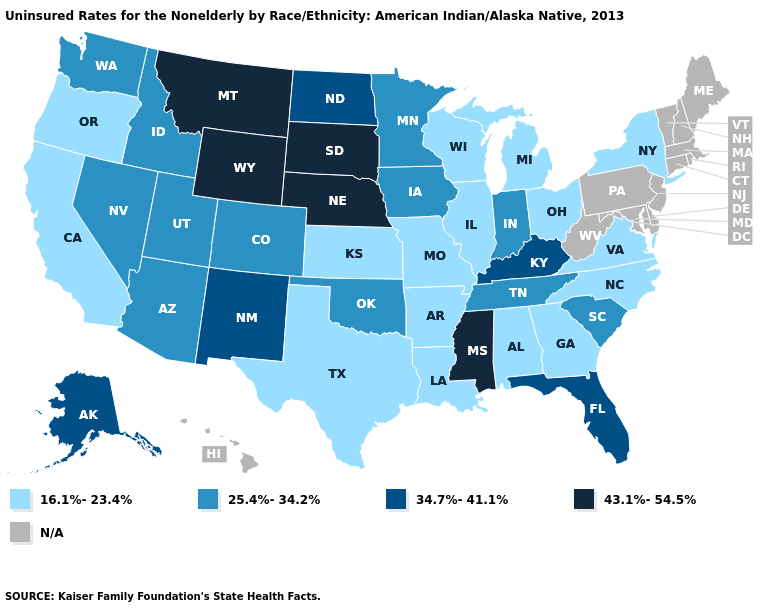What is the value of Nevada?
Write a very short answer. 25.4%-34.2%. Is the legend a continuous bar?
Give a very brief answer. No. Name the states that have a value in the range 43.1%-54.5%?
Concise answer only. Mississippi, Montana, Nebraska, South Dakota, Wyoming. Does the map have missing data?
Answer briefly. Yes. What is the highest value in the South ?
Answer briefly. 43.1%-54.5%. Does Washington have the lowest value in the West?
Concise answer only. No. Name the states that have a value in the range 34.7%-41.1%?
Keep it brief. Alaska, Florida, Kentucky, New Mexico, North Dakota. What is the value of Pennsylvania?
Answer briefly. N/A. What is the value of New Hampshire?
Write a very short answer. N/A. Among the states that border Massachusetts , which have the highest value?
Quick response, please. New York. What is the value of New York?
Write a very short answer. 16.1%-23.4%. Among the states that border Colorado , which have the highest value?
Short answer required. Nebraska, Wyoming. What is the value of Ohio?
Quick response, please. 16.1%-23.4%. Does Wyoming have the highest value in the USA?
Concise answer only. Yes. What is the value of Illinois?
Short answer required. 16.1%-23.4%. 